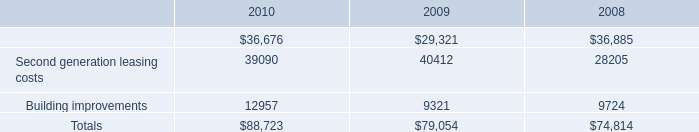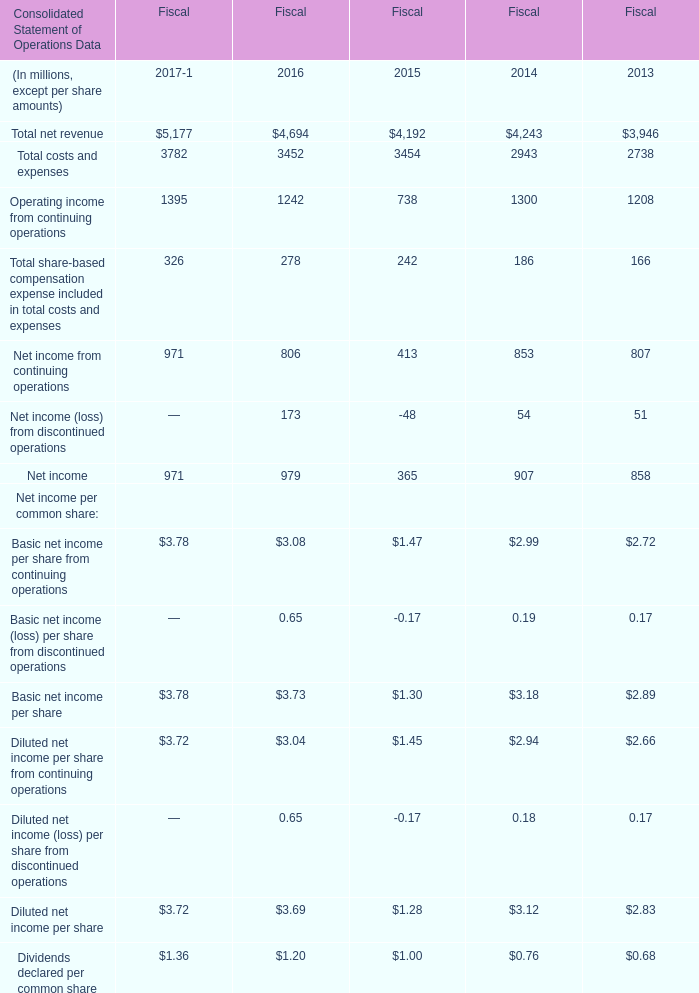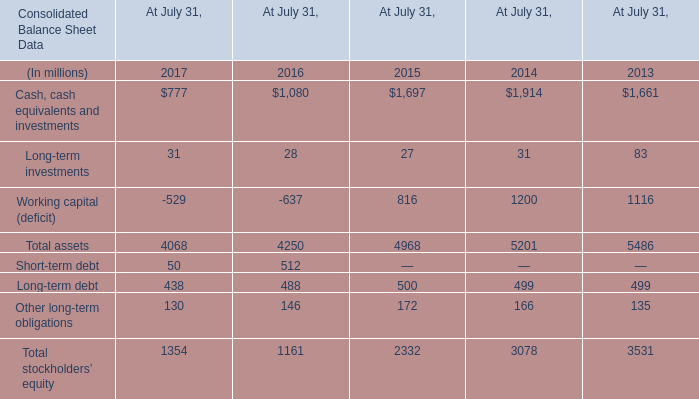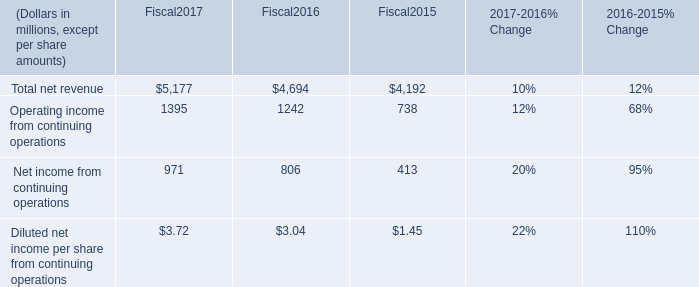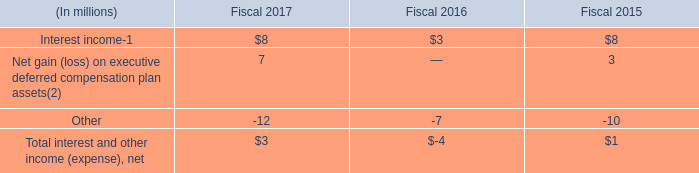If Long-term investments develops with the same growth rate in 2015, what will it reach in 2016? (in million) 
Computations: ((1 + ((27 - 31) / 31)) * 27)
Answer: 23.51613. 